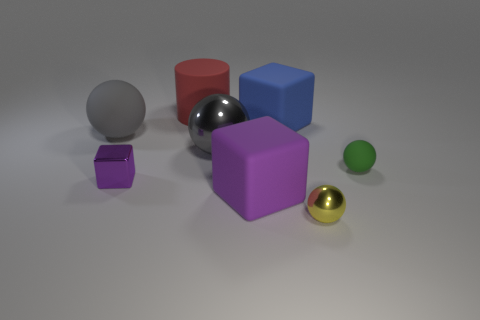Do the large metal ball and the big matte sphere have the same color?
Provide a succinct answer. Yes. What number of gray objects are tiny matte objects or large matte things?
Your answer should be very brief. 1. How many tiny purple things have the same shape as the large red matte thing?
Provide a short and direct response. 0. There is a gray rubber thing that is the same size as the matte cylinder; what is its shape?
Your answer should be compact. Sphere. There is a large gray rubber sphere; are there any small yellow objects to the right of it?
Your response must be concise. Yes. Are there any metallic objects in front of the matte object in front of the green sphere?
Your answer should be compact. Yes. Is the number of purple shiny blocks right of the red cylinder less than the number of large blue cubes that are in front of the large purple thing?
Your answer should be very brief. No. The red rubber object is what shape?
Give a very brief answer. Cylinder. There is a ball that is to the right of the small metallic ball; what is it made of?
Your answer should be very brief. Rubber. There is a metallic object to the right of the large block that is behind the purple cube that is in front of the tiny shiny block; what is its size?
Keep it short and to the point. Small. 